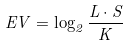Convert formula to latex. <formula><loc_0><loc_0><loc_500><loc_500>E V = \log _ { 2 } \frac { L \cdot S } { K }</formula> 